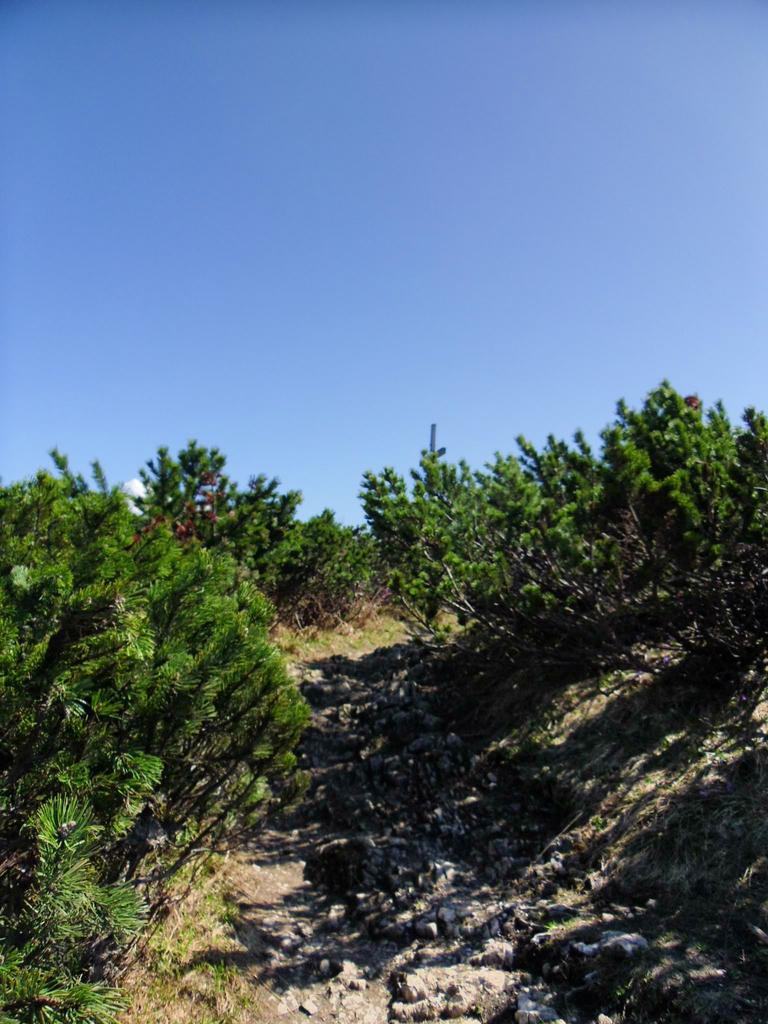Could you give a brief overview of what you see in this image? In the image there are plants around the rock surface. 